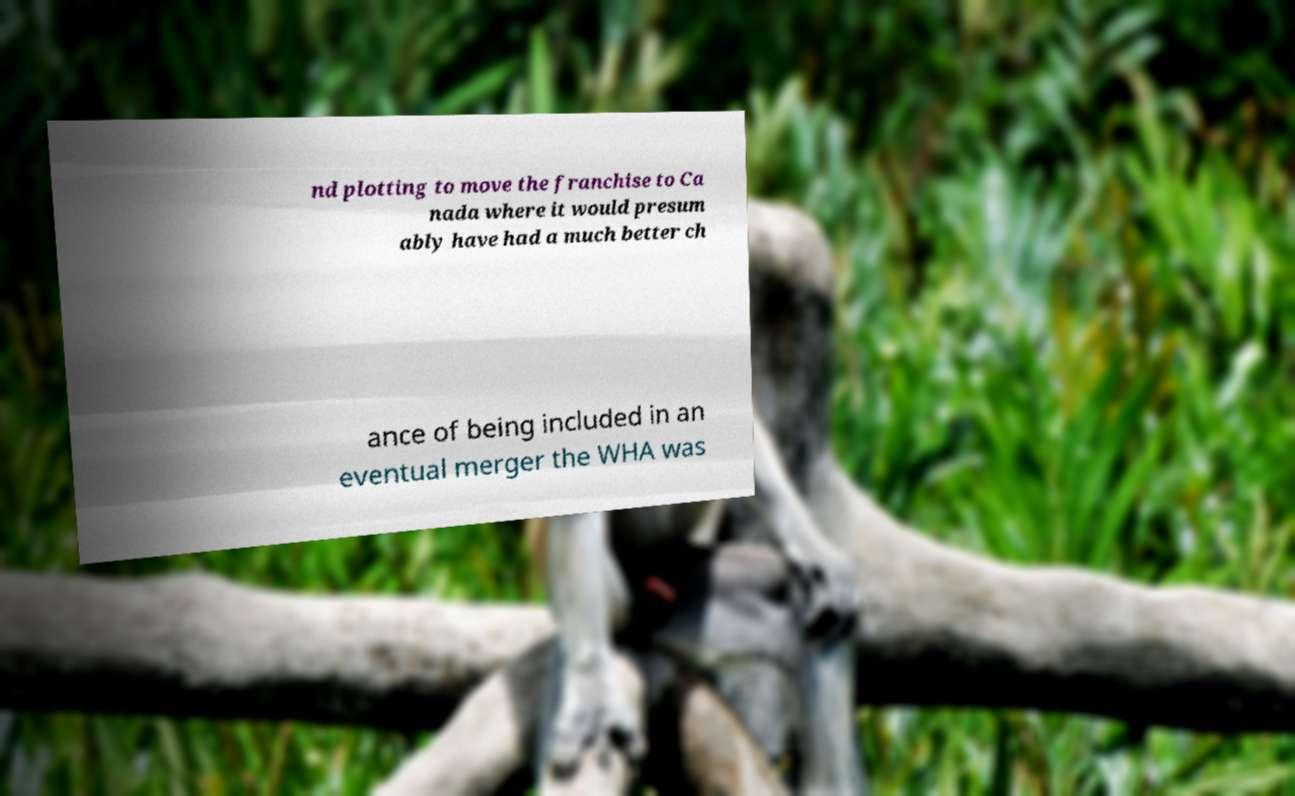For documentation purposes, I need the text within this image transcribed. Could you provide that? nd plotting to move the franchise to Ca nada where it would presum ably have had a much better ch ance of being included in an eventual merger the WHA was 